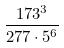<formula> <loc_0><loc_0><loc_500><loc_500>\frac { 1 7 3 ^ { 3 } } { 2 7 7 \cdot 5 ^ { 6 } }</formula> 